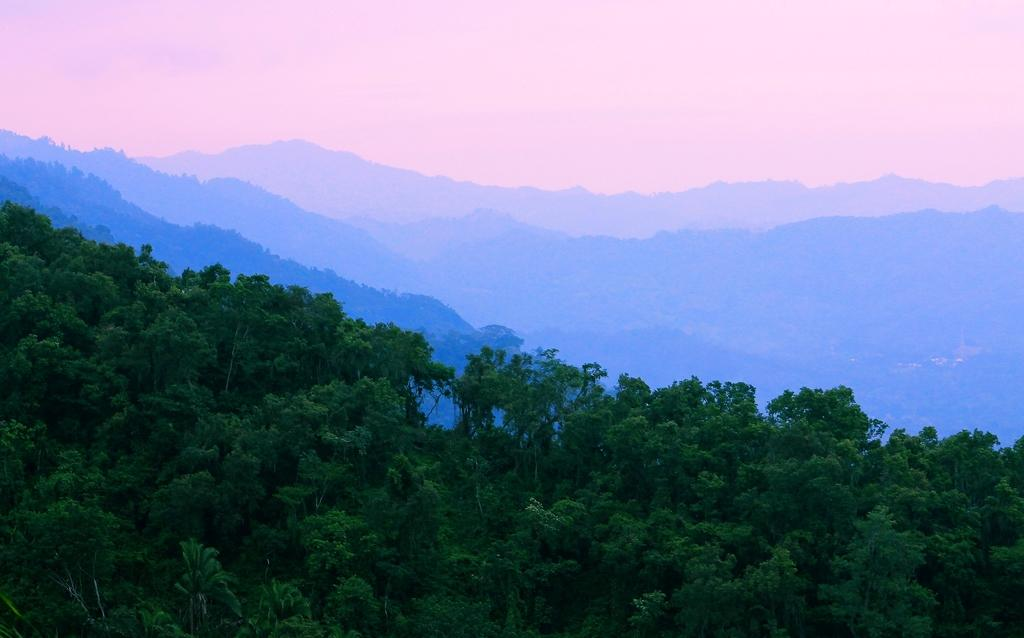What can be seen at the top of the image? The sky is visible in the image. What type of landscape feature is present in the image? There are hills in the image. What type of vegetation can be seen in the image? Trees are present in the image. What type of advertisement can be seen on someone's nose in the image? There is no advertisement or person with a nose present in the image. How many wrists are visible in the image? There are no wrists visible in the image. 